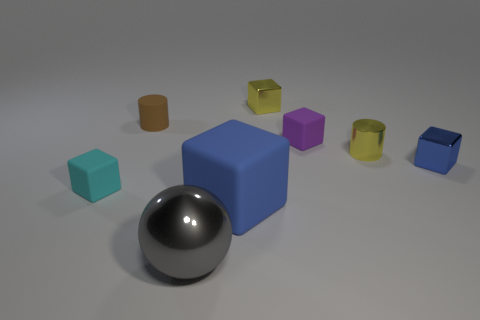Subtract 1 cubes. How many cubes are left? 4 Subtract all purple cubes. How many cubes are left? 4 Subtract all big cubes. How many cubes are left? 4 Subtract all green cubes. Subtract all brown balls. How many cubes are left? 5 Add 1 big things. How many objects exist? 9 Subtract all balls. How many objects are left? 7 Add 1 brown rubber cylinders. How many brown rubber cylinders exist? 2 Subtract 0 brown spheres. How many objects are left? 8 Subtract all small yellow shiny cylinders. Subtract all tiny cyan rubber objects. How many objects are left? 6 Add 4 tiny brown things. How many tiny brown things are left? 5 